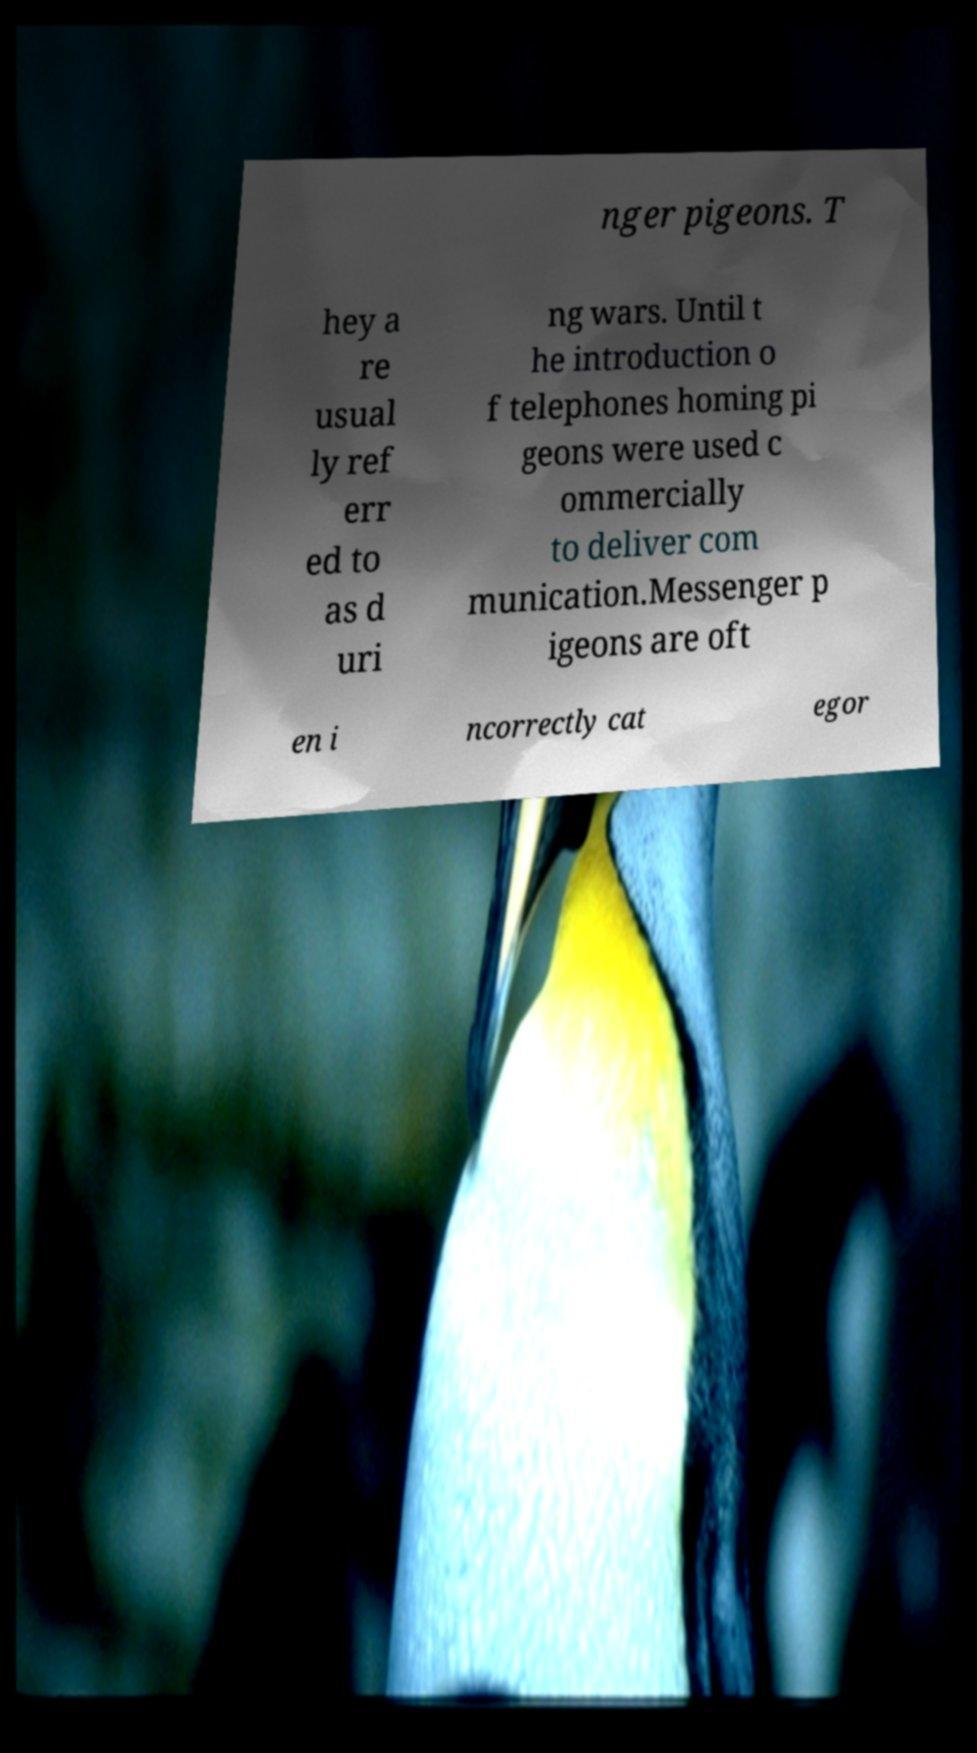There's text embedded in this image that I need extracted. Can you transcribe it verbatim? nger pigeons. T hey a re usual ly ref err ed to as d uri ng wars. Until t he introduction o f telephones homing pi geons were used c ommercially to deliver com munication.Messenger p igeons are oft en i ncorrectly cat egor 